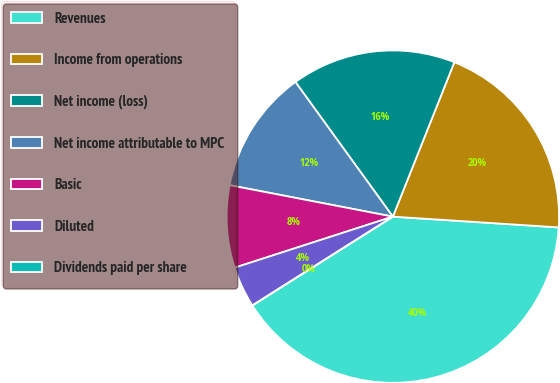<chart> <loc_0><loc_0><loc_500><loc_500><pie_chart><fcel>Revenues<fcel>Income from operations<fcel>Net income (loss)<fcel>Net income attributable to MPC<fcel>Basic<fcel>Diluted<fcel>Dividends paid per share<nl><fcel>40.0%<fcel>20.0%<fcel>16.0%<fcel>12.0%<fcel>8.0%<fcel>4.0%<fcel>0.0%<nl></chart> 